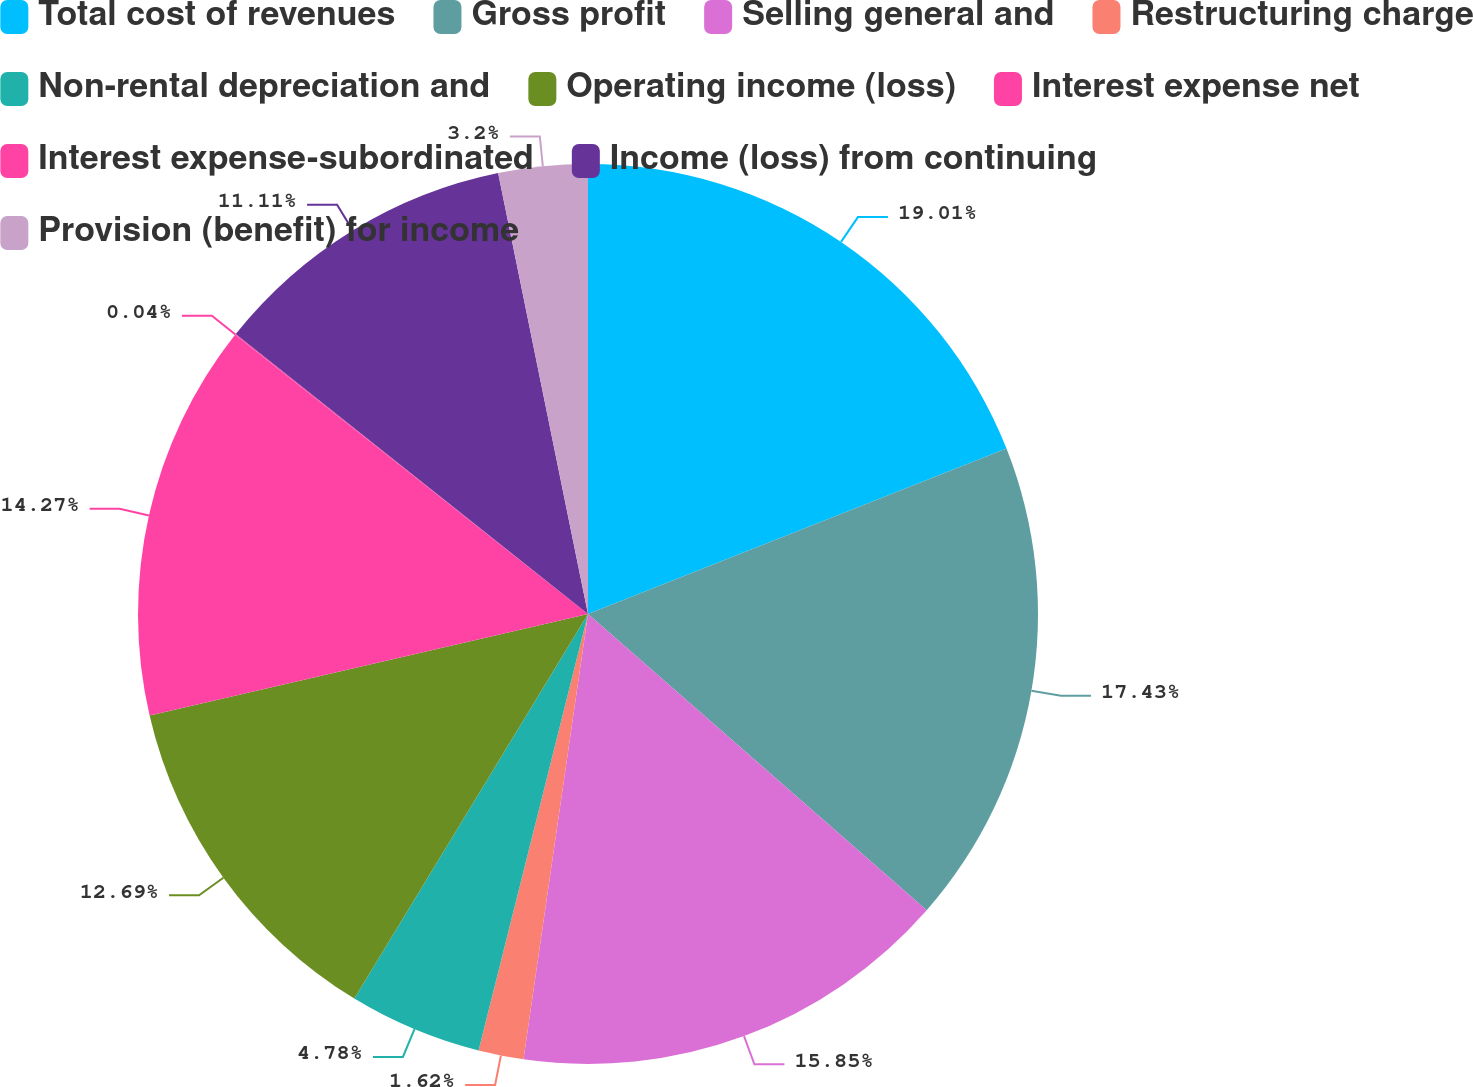Convert chart. <chart><loc_0><loc_0><loc_500><loc_500><pie_chart><fcel>Total cost of revenues<fcel>Gross profit<fcel>Selling general and<fcel>Restructuring charge<fcel>Non-rental depreciation and<fcel>Operating income (loss)<fcel>Interest expense net<fcel>Interest expense-subordinated<fcel>Income (loss) from continuing<fcel>Provision (benefit) for income<nl><fcel>19.01%<fcel>17.43%<fcel>15.85%<fcel>1.62%<fcel>4.78%<fcel>12.69%<fcel>14.27%<fcel>0.04%<fcel>11.11%<fcel>3.2%<nl></chart> 